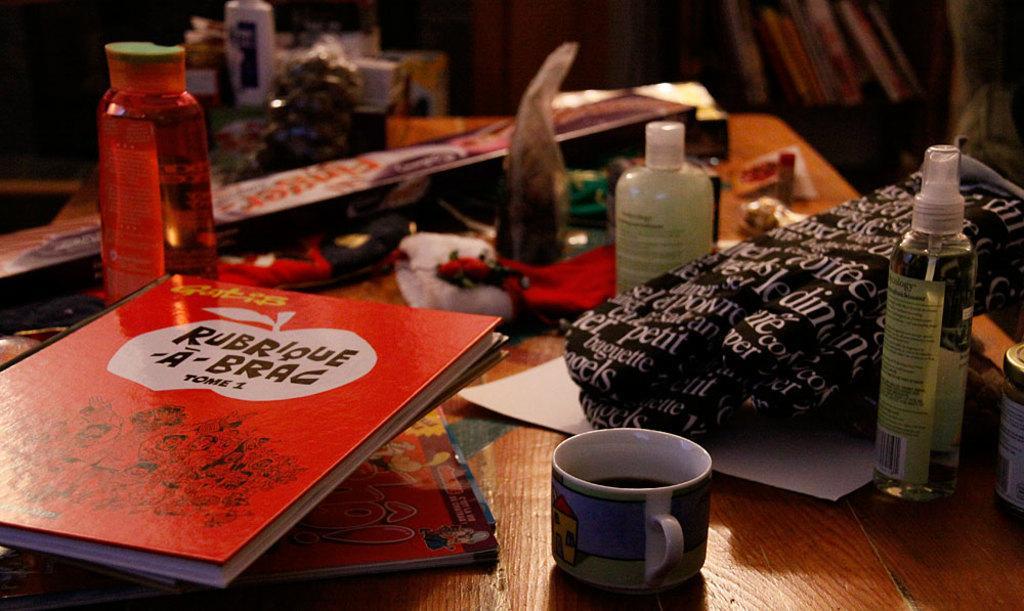Can you describe this image briefly? In this image I can see few bottles, a cup and few books. 